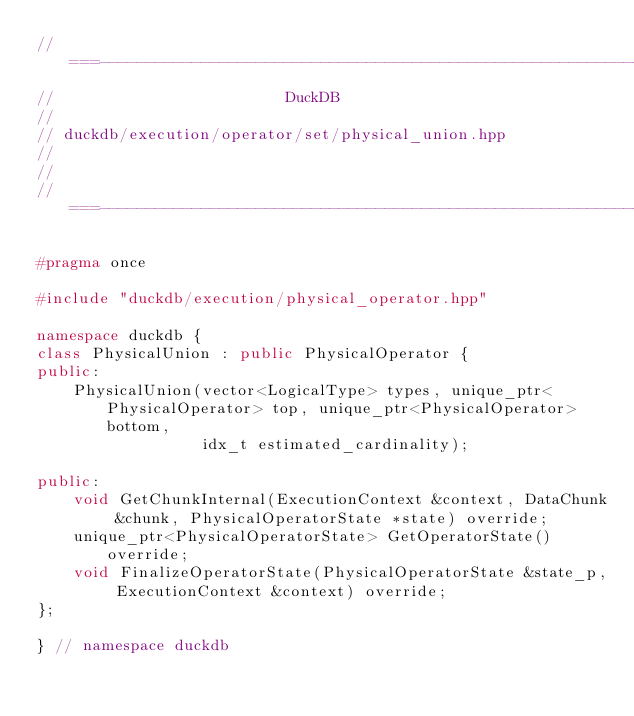<code> <loc_0><loc_0><loc_500><loc_500><_C++_>//===----------------------------------------------------------------------===//
//                         DuckDB
//
// duckdb/execution/operator/set/physical_union.hpp
//
//
//===----------------------------------------------------------------------===//

#pragma once

#include "duckdb/execution/physical_operator.hpp"

namespace duckdb {
class PhysicalUnion : public PhysicalOperator {
public:
	PhysicalUnion(vector<LogicalType> types, unique_ptr<PhysicalOperator> top, unique_ptr<PhysicalOperator> bottom,
	              idx_t estimated_cardinality);

public:
	void GetChunkInternal(ExecutionContext &context, DataChunk &chunk, PhysicalOperatorState *state) override;
	unique_ptr<PhysicalOperatorState> GetOperatorState() override;
	void FinalizeOperatorState(PhysicalOperatorState &state_p, ExecutionContext &context) override;
};

} // namespace duckdb
</code> 